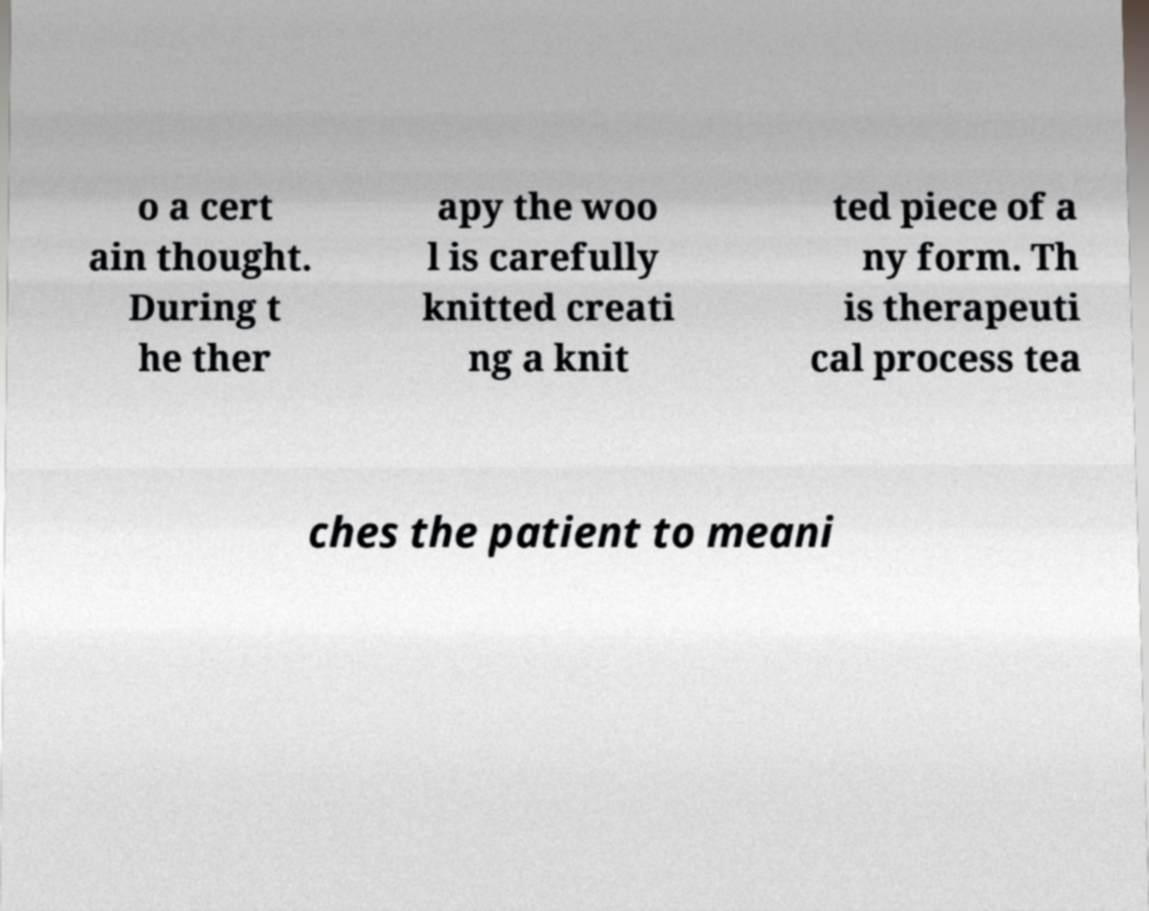For documentation purposes, I need the text within this image transcribed. Could you provide that? o a cert ain thought. During t he ther apy the woo l is carefully knitted creati ng a knit ted piece of a ny form. Th is therapeuti cal process tea ches the patient to meani 